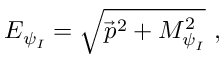<formula> <loc_0><loc_0><loc_500><loc_500>E _ { \psi _ { I } } = \sqrt { \vec { p } ^ { 2 } + M _ { \psi _ { I } } ^ { 2 } } \ ,</formula> 